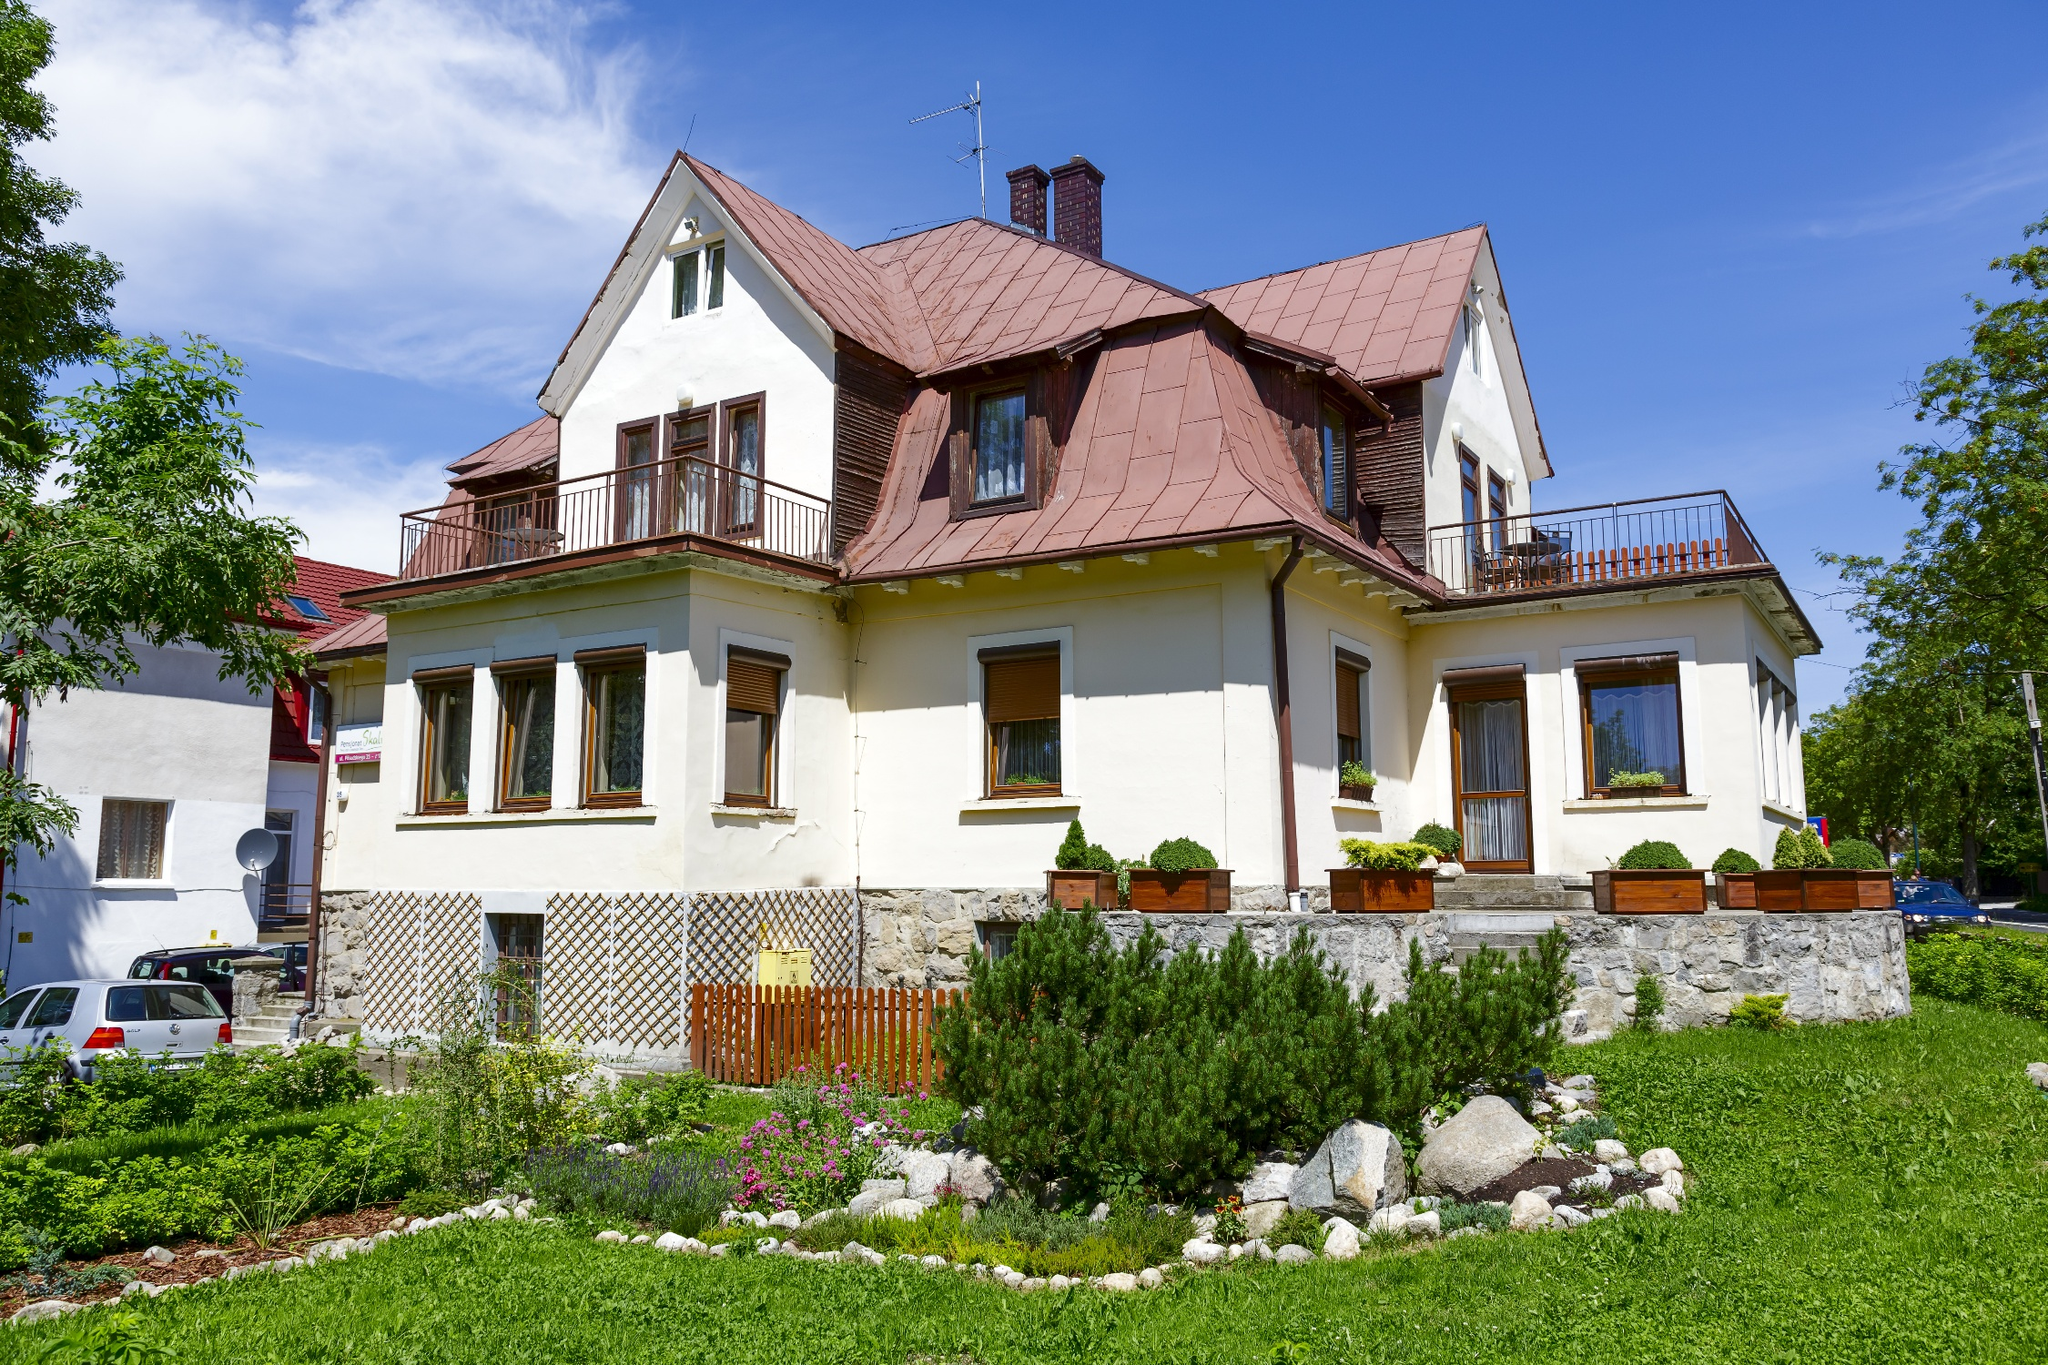Can you tell me more about the architectural style of this house? Certainly! The house features a combination of classical and modern elements. The use of a gabled roof and symmetrical windows hints at a traditional architectural influence, possibly European. In contrast, the broad porch and open balcony with metal railings incorporate more contemporary touches. This blend of styles makes the house uniquely charming and functional, providing both aesthetic pleasure and practical benefits like natural light and outdoor spaces for relaxation. 